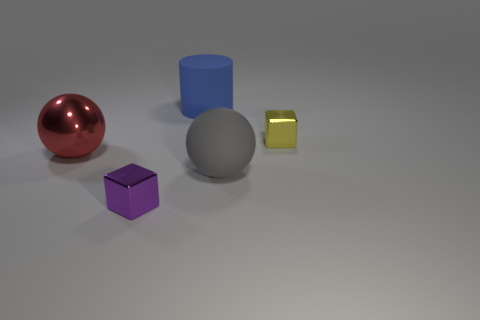Subtract all red cubes. How many gray spheres are left? 1 Subtract all yellow cubes. How many cubes are left? 1 Subtract all blue metallic balls. Subtract all large gray matte things. How many objects are left? 4 Add 1 big metallic objects. How many big metallic objects are left? 2 Add 5 large rubber cylinders. How many large rubber cylinders exist? 6 Add 1 big purple matte balls. How many objects exist? 6 Subtract 1 purple blocks. How many objects are left? 4 Subtract all cylinders. How many objects are left? 4 Subtract 1 cylinders. How many cylinders are left? 0 Subtract all purple cylinders. Subtract all gray blocks. How many cylinders are left? 1 